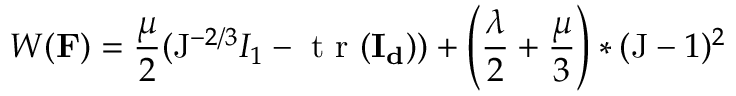<formula> <loc_0><loc_0><loc_500><loc_500>{ W } ( F ) = \frac { \mu } { 2 } ( J ^ { - 2 / 3 } I _ { 1 } - t r ( I _ { d } ) ) + \left ( \frac { \lambda } { 2 } + \frac { \mu } { 3 } \right ) * ( J - 1 ) ^ { 2 }</formula> 